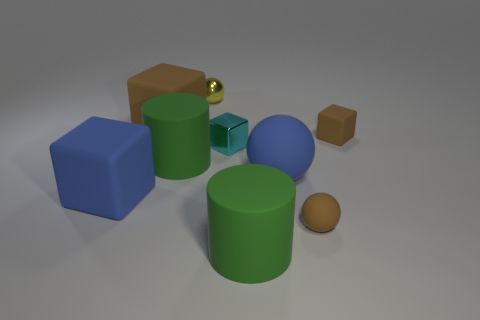Subtract 1 blocks. How many blocks are left? 3 Subtract all blocks. How many objects are left? 5 Add 3 brown matte things. How many brown matte things exist? 6 Subtract 0 yellow cylinders. How many objects are left? 9 Subtract all large matte objects. Subtract all tiny matte objects. How many objects are left? 2 Add 6 tiny cyan blocks. How many tiny cyan blocks are left? 7 